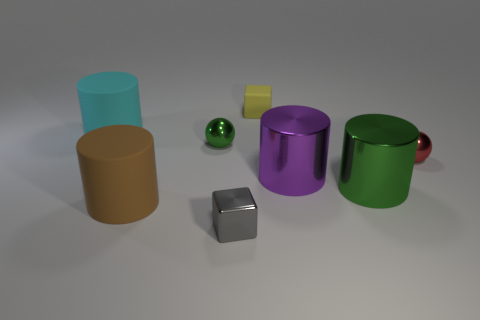Subtract all big purple cylinders. How many cylinders are left? 3 Add 2 large gray shiny balls. How many objects exist? 10 Subtract all green cylinders. How many cylinders are left? 3 Subtract all balls. How many objects are left? 6 Subtract 2 balls. How many balls are left? 0 Subtract all large gray metallic cylinders. Subtract all gray metallic blocks. How many objects are left? 7 Add 5 red metal objects. How many red metal objects are left? 6 Add 8 matte cylinders. How many matte cylinders exist? 10 Subtract 0 gray cylinders. How many objects are left? 8 Subtract all yellow spheres. Subtract all gray cylinders. How many spheres are left? 2 